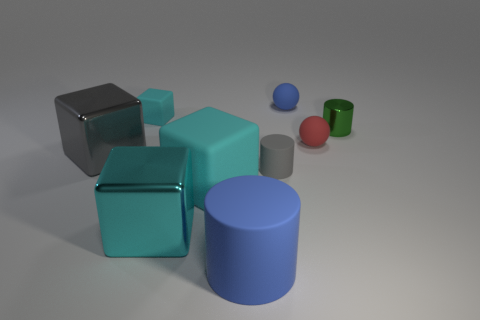Subtract all purple cylinders. How many cyan blocks are left? 3 Subtract all cyan blocks. How many blocks are left? 1 Subtract 2 cubes. How many cubes are left? 2 Subtract all gray blocks. How many blocks are left? 3 Subtract all brown blocks. Subtract all purple cylinders. How many blocks are left? 4 Subtract all cylinders. How many objects are left? 6 Add 3 green blocks. How many green blocks exist? 3 Subtract 0 brown balls. How many objects are left? 9 Subtract all red cylinders. Subtract all gray blocks. How many objects are left? 8 Add 5 blue matte spheres. How many blue matte spheres are left? 6 